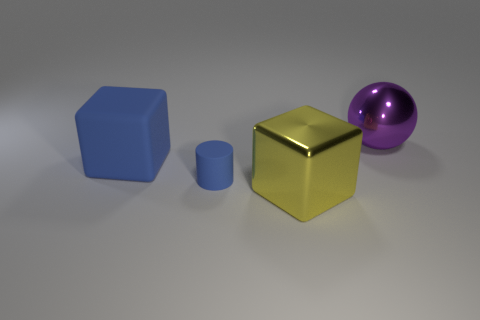If these objects were to represent a family, which roles might each object assume? If we interpret the objects as a family, the large blue object could be seen as a parental figure due to its size, the gold cube might be the other parent, or perhaps the one with a 'golden' personality, and the purple one could be interpreted as the playful child due to its spherical shape and vibrant color. The small blue cylinder might be seen as a pet or a younger sibling, considering its smaller size. 